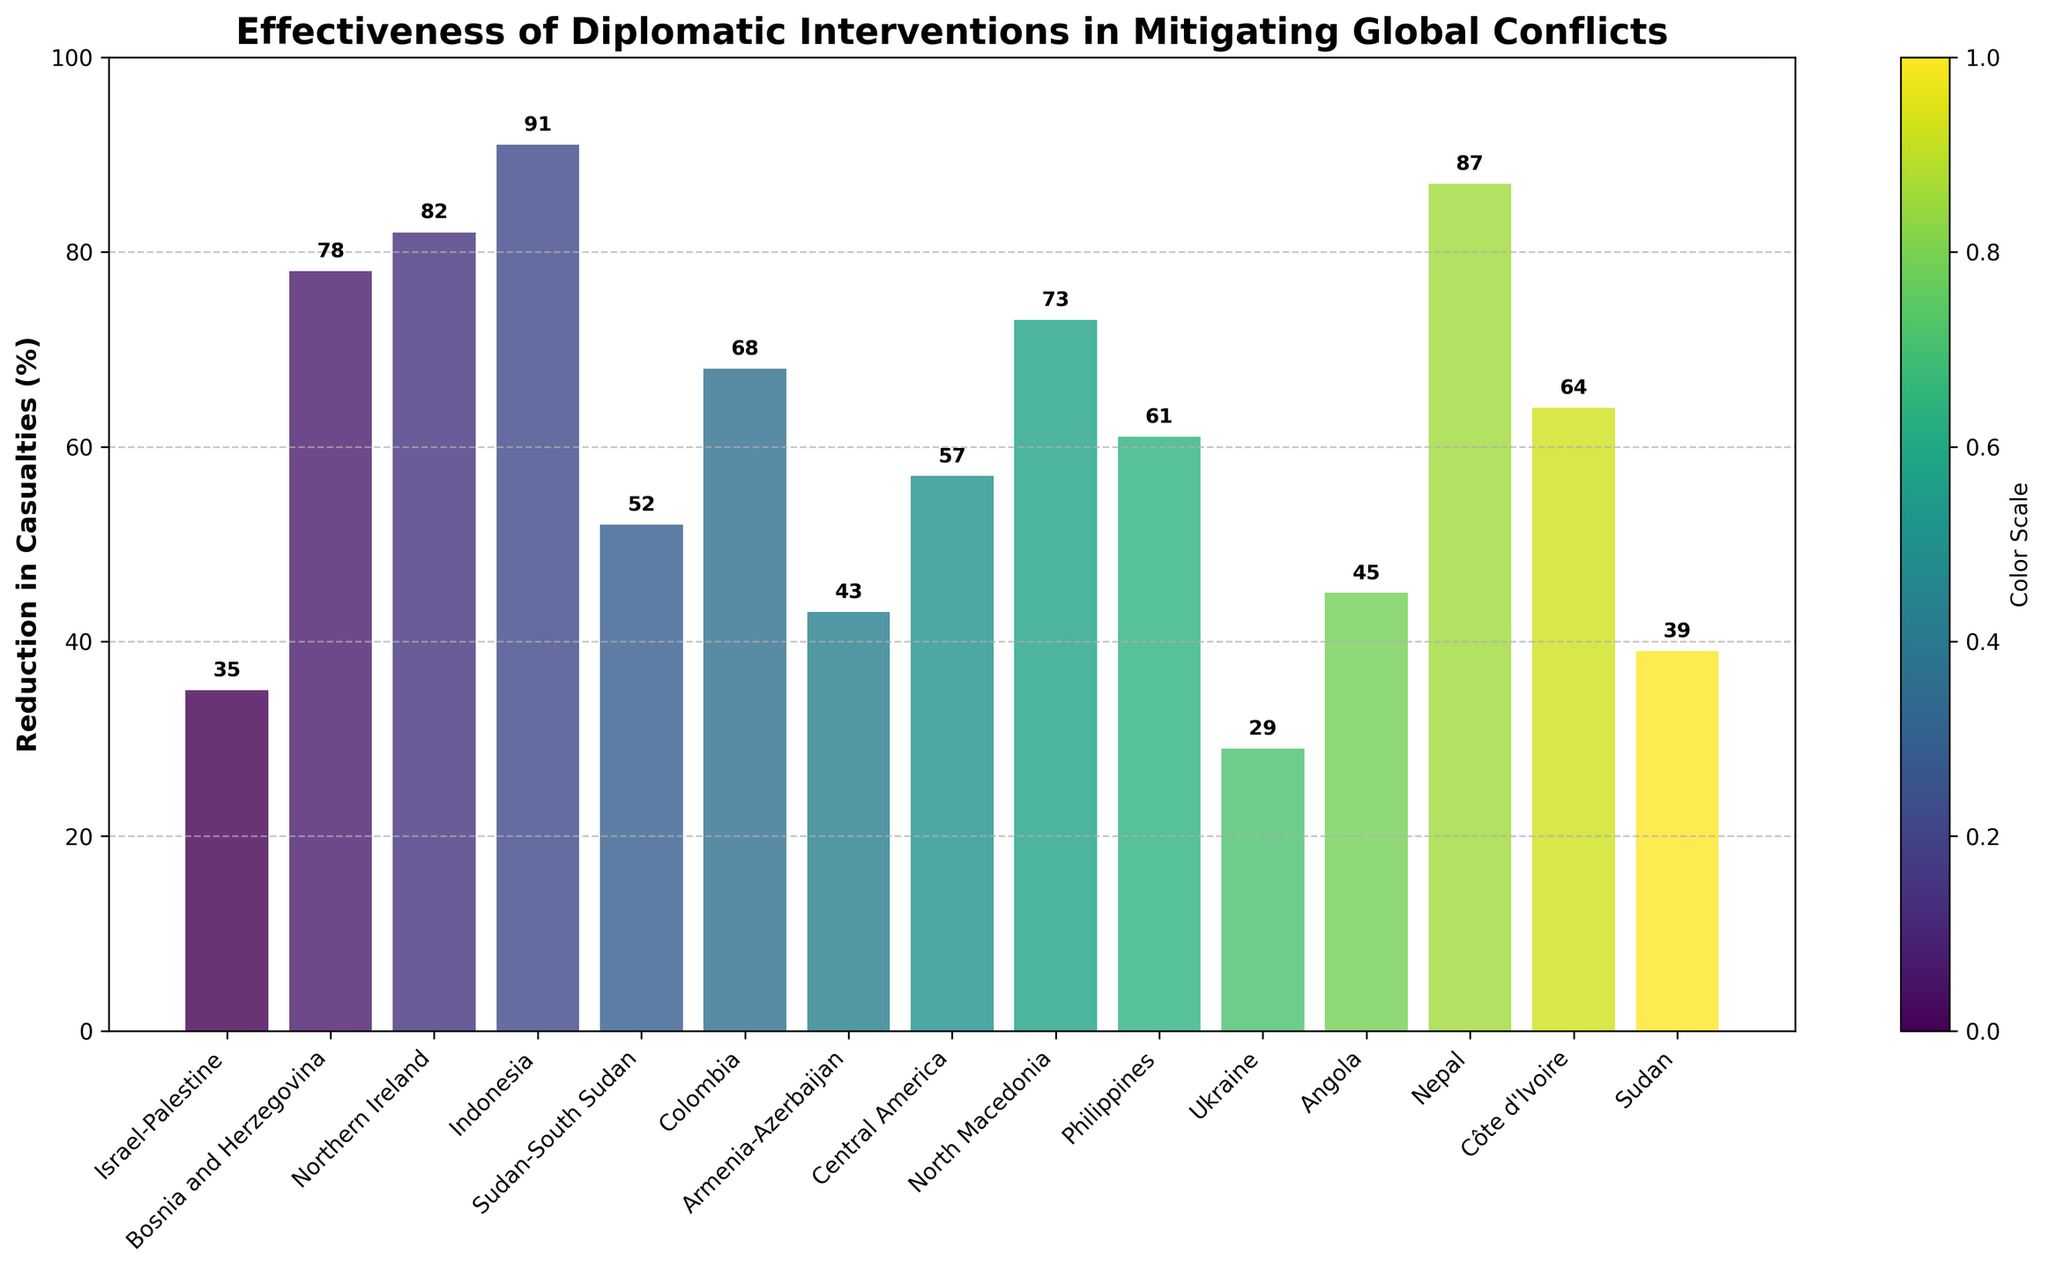Conflict reduction in which diplomatic intervention witnessed the highest percentage decrease? By identifying the highest bar in the chart, we see that the Aceh Peace Agreement intervention has the highest reduction percentage.
Answer: Aceh Peace Agreement, 91% Which time period had the least effective diplomatic intervention in terms of casualty reduction? Finding the shortest bar in the plot, one can see that the Minsk Agreements during 2015-2020 had the lowest reduction percentage.
Answer: 2015-2020, Minsk Agreements, 29% How do the casualty reductions compare between the Oslo Accords and the Dayton Agreement? Examining the lengths of the bars for the Oslo Accords and Dayton Agreement, we see that the Dayton Agreement bar is significantly taller, showing a higher reduction. The percentages are 35% and 78% respectively.
Answer: Dayton Agreement, 78% > Oslo Accords, 35% What is the total percentage reduction in casualties for peace agreements from 2000-2005? Adding the reductions for Good Friday Agreement (82%) and Ohrid Agreement (73%) gives 82 + 73 = 155%.
Answer: 155% Calculate the average reduction in casualties for the interventions from 2010-2015. The reductions are 52%, 61%, 64%, and 50% for this period. The sum is 52 + 61 + 64 + 50 = 227. Dividing by 4 gives the average 227/4 = 56.75%.
Answer: 56.75% Which conflict region shows a reduction closest to 50% and name the related diplomatic intervention? The visual length of bars close to 50% include the Comprehensive Peace Agreement for Sudan-South Sudan at 52%.
Answer: Sudan-South Sudan, Comprehensive Peace Agreement What was the visual difference in reduction percentages between the Mindanao Peace Process and the Juba Agreement? Comparing the heights of the bars for Mindanao (61%) and Juba (39%), the difference is 61-39 = 22%.
Answer: 22% Identify all the conflicts with a reduction greater than 60% but less than 80% with their respective agreements. We observe the heights of the bars within the specified range, identifying the Dayton Agreement (78%), Good Friday Agreement (82%), Ohrid Agreement (73%), Mindanao Peace Process (61%), and Ouagadougou Agreement (64%).
Answer: Bosnia and Herzegovina, North Macedonia, Philippines, Côte d'Ivoire What is the ratio of the reduction percentage of the Aceh Peace Agreement to the Minsk Agreements? Ratio is found by dividing the reduction percentage of Aceh (91%) by Minsk (29%) resulting in 91/29 ≈ 3.14.
Answer: 3.14 Among the interventions in the period 1995-2000, which one had the lowest reduction in casualties? Observing the bars for this period, the Lusaka Protocol in Angola shows the lowest reduction at 45%.
Answer: Lusaka Protocol, 45% 